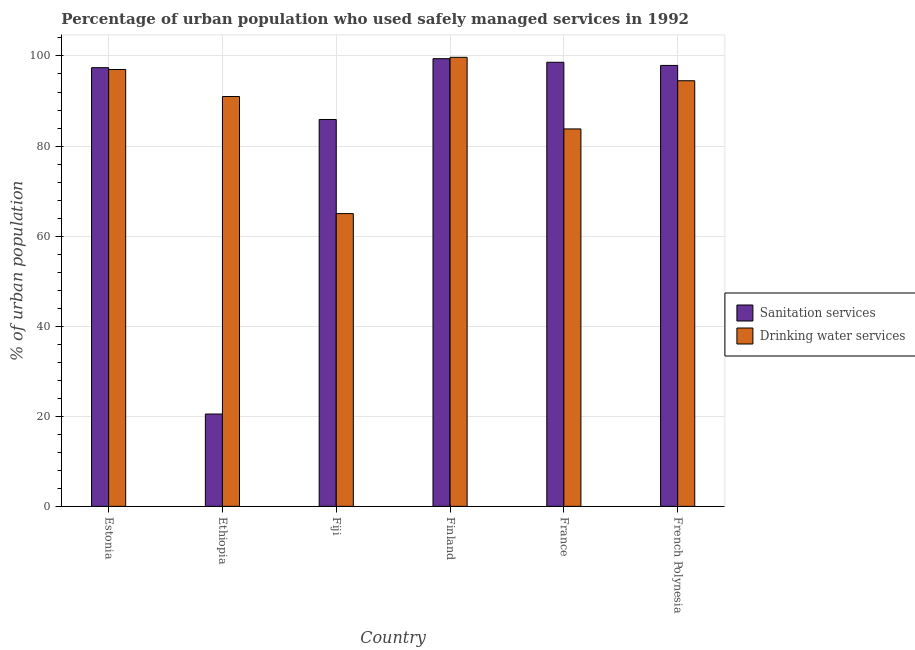How many groups of bars are there?
Keep it short and to the point. 6. Are the number of bars on each tick of the X-axis equal?
Offer a very short reply. Yes. How many bars are there on the 2nd tick from the left?
Offer a terse response. 2. How many bars are there on the 2nd tick from the right?
Make the answer very short. 2. What is the label of the 1st group of bars from the left?
Your response must be concise. Estonia. In how many cases, is the number of bars for a given country not equal to the number of legend labels?
Provide a short and direct response. 0. What is the percentage of urban population who used drinking water services in French Polynesia?
Offer a terse response. 94.5. Across all countries, what is the maximum percentage of urban population who used sanitation services?
Offer a very short reply. 99.4. Across all countries, what is the minimum percentage of urban population who used drinking water services?
Offer a very short reply. 65. In which country was the percentage of urban population who used sanitation services minimum?
Offer a terse response. Ethiopia. What is the total percentage of urban population who used sanitation services in the graph?
Your response must be concise. 499.7. What is the difference between the percentage of urban population who used sanitation services in Finland and that in France?
Give a very brief answer. 0.8. What is the difference between the percentage of urban population who used sanitation services in French Polynesia and the percentage of urban population who used drinking water services in Estonia?
Your answer should be compact. 0.9. What is the average percentage of urban population who used drinking water services per country?
Your answer should be compact. 88.5. What is the difference between the percentage of urban population who used sanitation services and percentage of urban population who used drinking water services in Fiji?
Your answer should be very brief. 20.9. In how many countries, is the percentage of urban population who used sanitation services greater than 20 %?
Your answer should be compact. 6. What is the ratio of the percentage of urban population who used drinking water services in France to that in French Polynesia?
Your answer should be compact. 0.89. Is the percentage of urban population who used sanitation services in Ethiopia less than that in Finland?
Give a very brief answer. Yes. What is the difference between the highest and the second highest percentage of urban population who used drinking water services?
Your answer should be compact. 2.7. What is the difference between the highest and the lowest percentage of urban population who used sanitation services?
Offer a terse response. 78.9. In how many countries, is the percentage of urban population who used drinking water services greater than the average percentage of urban population who used drinking water services taken over all countries?
Keep it short and to the point. 4. Is the sum of the percentage of urban population who used sanitation services in Ethiopia and Fiji greater than the maximum percentage of urban population who used drinking water services across all countries?
Offer a terse response. Yes. What does the 1st bar from the left in Ethiopia represents?
Provide a short and direct response. Sanitation services. What does the 1st bar from the right in French Polynesia represents?
Provide a succinct answer. Drinking water services. How many bars are there?
Ensure brevity in your answer.  12. What is the difference between two consecutive major ticks on the Y-axis?
Give a very brief answer. 20. Are the values on the major ticks of Y-axis written in scientific E-notation?
Your answer should be very brief. No. Does the graph contain any zero values?
Provide a succinct answer. No. Does the graph contain grids?
Make the answer very short. Yes. What is the title of the graph?
Ensure brevity in your answer.  Percentage of urban population who used safely managed services in 1992. Does "Fraud firms" appear as one of the legend labels in the graph?
Offer a terse response. No. What is the label or title of the X-axis?
Provide a succinct answer. Country. What is the label or title of the Y-axis?
Ensure brevity in your answer.  % of urban population. What is the % of urban population in Sanitation services in Estonia?
Provide a short and direct response. 97.4. What is the % of urban population in Drinking water services in Estonia?
Your response must be concise. 97. What is the % of urban population in Drinking water services in Ethiopia?
Your answer should be compact. 91. What is the % of urban population in Sanitation services in Fiji?
Keep it short and to the point. 85.9. What is the % of urban population of Sanitation services in Finland?
Your response must be concise. 99.4. What is the % of urban population of Drinking water services in Finland?
Make the answer very short. 99.7. What is the % of urban population in Sanitation services in France?
Give a very brief answer. 98.6. What is the % of urban population of Drinking water services in France?
Ensure brevity in your answer.  83.8. What is the % of urban population in Sanitation services in French Polynesia?
Ensure brevity in your answer.  97.9. What is the % of urban population in Drinking water services in French Polynesia?
Provide a succinct answer. 94.5. Across all countries, what is the maximum % of urban population of Sanitation services?
Offer a terse response. 99.4. Across all countries, what is the maximum % of urban population of Drinking water services?
Provide a short and direct response. 99.7. Across all countries, what is the minimum % of urban population in Sanitation services?
Offer a terse response. 20.5. Across all countries, what is the minimum % of urban population in Drinking water services?
Your answer should be very brief. 65. What is the total % of urban population in Sanitation services in the graph?
Provide a succinct answer. 499.7. What is the total % of urban population of Drinking water services in the graph?
Offer a very short reply. 531. What is the difference between the % of urban population in Sanitation services in Estonia and that in Ethiopia?
Your response must be concise. 76.9. What is the difference between the % of urban population in Drinking water services in Estonia and that in Ethiopia?
Keep it short and to the point. 6. What is the difference between the % of urban population of Sanitation services in Estonia and that in Finland?
Offer a terse response. -2. What is the difference between the % of urban population in Drinking water services in Estonia and that in Finland?
Give a very brief answer. -2.7. What is the difference between the % of urban population in Sanitation services in Estonia and that in France?
Provide a succinct answer. -1.2. What is the difference between the % of urban population of Drinking water services in Estonia and that in France?
Your answer should be very brief. 13.2. What is the difference between the % of urban population of Sanitation services in Ethiopia and that in Fiji?
Offer a very short reply. -65.4. What is the difference between the % of urban population of Sanitation services in Ethiopia and that in Finland?
Your answer should be compact. -78.9. What is the difference between the % of urban population in Sanitation services in Ethiopia and that in France?
Ensure brevity in your answer.  -78.1. What is the difference between the % of urban population in Drinking water services in Ethiopia and that in France?
Provide a succinct answer. 7.2. What is the difference between the % of urban population in Sanitation services in Ethiopia and that in French Polynesia?
Make the answer very short. -77.4. What is the difference between the % of urban population in Drinking water services in Fiji and that in Finland?
Keep it short and to the point. -34.7. What is the difference between the % of urban population in Sanitation services in Fiji and that in France?
Your answer should be very brief. -12.7. What is the difference between the % of urban population of Drinking water services in Fiji and that in France?
Offer a very short reply. -18.8. What is the difference between the % of urban population of Drinking water services in Fiji and that in French Polynesia?
Provide a succinct answer. -29.5. What is the difference between the % of urban population of Drinking water services in Finland and that in France?
Your answer should be compact. 15.9. What is the difference between the % of urban population in Sanitation services in Finland and that in French Polynesia?
Offer a terse response. 1.5. What is the difference between the % of urban population of Drinking water services in Finland and that in French Polynesia?
Offer a terse response. 5.2. What is the difference between the % of urban population of Sanitation services in Estonia and the % of urban population of Drinking water services in Fiji?
Ensure brevity in your answer.  32.4. What is the difference between the % of urban population in Sanitation services in Ethiopia and the % of urban population in Drinking water services in Fiji?
Provide a short and direct response. -44.5. What is the difference between the % of urban population in Sanitation services in Ethiopia and the % of urban population in Drinking water services in Finland?
Keep it short and to the point. -79.2. What is the difference between the % of urban population in Sanitation services in Ethiopia and the % of urban population in Drinking water services in France?
Offer a very short reply. -63.3. What is the difference between the % of urban population of Sanitation services in Ethiopia and the % of urban population of Drinking water services in French Polynesia?
Give a very brief answer. -74. What is the difference between the % of urban population in Sanitation services in Fiji and the % of urban population in Drinking water services in Finland?
Ensure brevity in your answer.  -13.8. What is the difference between the % of urban population in Sanitation services in Fiji and the % of urban population in Drinking water services in France?
Your response must be concise. 2.1. What is the difference between the % of urban population in Sanitation services in Fiji and the % of urban population in Drinking water services in French Polynesia?
Offer a terse response. -8.6. What is the difference between the % of urban population in Sanitation services in Finland and the % of urban population in Drinking water services in France?
Your answer should be compact. 15.6. What is the difference between the % of urban population in Sanitation services in France and the % of urban population in Drinking water services in French Polynesia?
Your answer should be compact. 4.1. What is the average % of urban population of Sanitation services per country?
Offer a very short reply. 83.28. What is the average % of urban population in Drinking water services per country?
Offer a very short reply. 88.5. What is the difference between the % of urban population in Sanitation services and % of urban population in Drinking water services in Ethiopia?
Keep it short and to the point. -70.5. What is the difference between the % of urban population of Sanitation services and % of urban population of Drinking water services in Fiji?
Give a very brief answer. 20.9. What is the ratio of the % of urban population in Sanitation services in Estonia to that in Ethiopia?
Offer a terse response. 4.75. What is the ratio of the % of urban population in Drinking water services in Estonia to that in Ethiopia?
Offer a terse response. 1.07. What is the ratio of the % of urban population in Sanitation services in Estonia to that in Fiji?
Your response must be concise. 1.13. What is the ratio of the % of urban population of Drinking water services in Estonia to that in Fiji?
Keep it short and to the point. 1.49. What is the ratio of the % of urban population of Sanitation services in Estonia to that in Finland?
Your answer should be compact. 0.98. What is the ratio of the % of urban population of Drinking water services in Estonia to that in Finland?
Your response must be concise. 0.97. What is the ratio of the % of urban population in Sanitation services in Estonia to that in France?
Make the answer very short. 0.99. What is the ratio of the % of urban population in Drinking water services in Estonia to that in France?
Provide a short and direct response. 1.16. What is the ratio of the % of urban population of Drinking water services in Estonia to that in French Polynesia?
Provide a short and direct response. 1.03. What is the ratio of the % of urban population of Sanitation services in Ethiopia to that in Fiji?
Provide a succinct answer. 0.24. What is the ratio of the % of urban population in Sanitation services in Ethiopia to that in Finland?
Your response must be concise. 0.21. What is the ratio of the % of urban population in Drinking water services in Ethiopia to that in Finland?
Your answer should be compact. 0.91. What is the ratio of the % of urban population in Sanitation services in Ethiopia to that in France?
Ensure brevity in your answer.  0.21. What is the ratio of the % of urban population in Drinking water services in Ethiopia to that in France?
Keep it short and to the point. 1.09. What is the ratio of the % of urban population of Sanitation services in Ethiopia to that in French Polynesia?
Ensure brevity in your answer.  0.21. What is the ratio of the % of urban population of Drinking water services in Ethiopia to that in French Polynesia?
Give a very brief answer. 0.96. What is the ratio of the % of urban population in Sanitation services in Fiji to that in Finland?
Offer a terse response. 0.86. What is the ratio of the % of urban population of Drinking water services in Fiji to that in Finland?
Provide a short and direct response. 0.65. What is the ratio of the % of urban population in Sanitation services in Fiji to that in France?
Offer a very short reply. 0.87. What is the ratio of the % of urban population in Drinking water services in Fiji to that in France?
Make the answer very short. 0.78. What is the ratio of the % of urban population in Sanitation services in Fiji to that in French Polynesia?
Provide a short and direct response. 0.88. What is the ratio of the % of urban population in Drinking water services in Fiji to that in French Polynesia?
Keep it short and to the point. 0.69. What is the ratio of the % of urban population of Drinking water services in Finland to that in France?
Your answer should be compact. 1.19. What is the ratio of the % of urban population of Sanitation services in Finland to that in French Polynesia?
Provide a short and direct response. 1.02. What is the ratio of the % of urban population in Drinking water services in Finland to that in French Polynesia?
Provide a succinct answer. 1.05. What is the ratio of the % of urban population in Sanitation services in France to that in French Polynesia?
Ensure brevity in your answer.  1.01. What is the ratio of the % of urban population in Drinking water services in France to that in French Polynesia?
Your answer should be very brief. 0.89. What is the difference between the highest and the second highest % of urban population in Sanitation services?
Provide a short and direct response. 0.8. What is the difference between the highest and the second highest % of urban population of Drinking water services?
Your response must be concise. 2.7. What is the difference between the highest and the lowest % of urban population in Sanitation services?
Your answer should be very brief. 78.9. What is the difference between the highest and the lowest % of urban population in Drinking water services?
Keep it short and to the point. 34.7. 